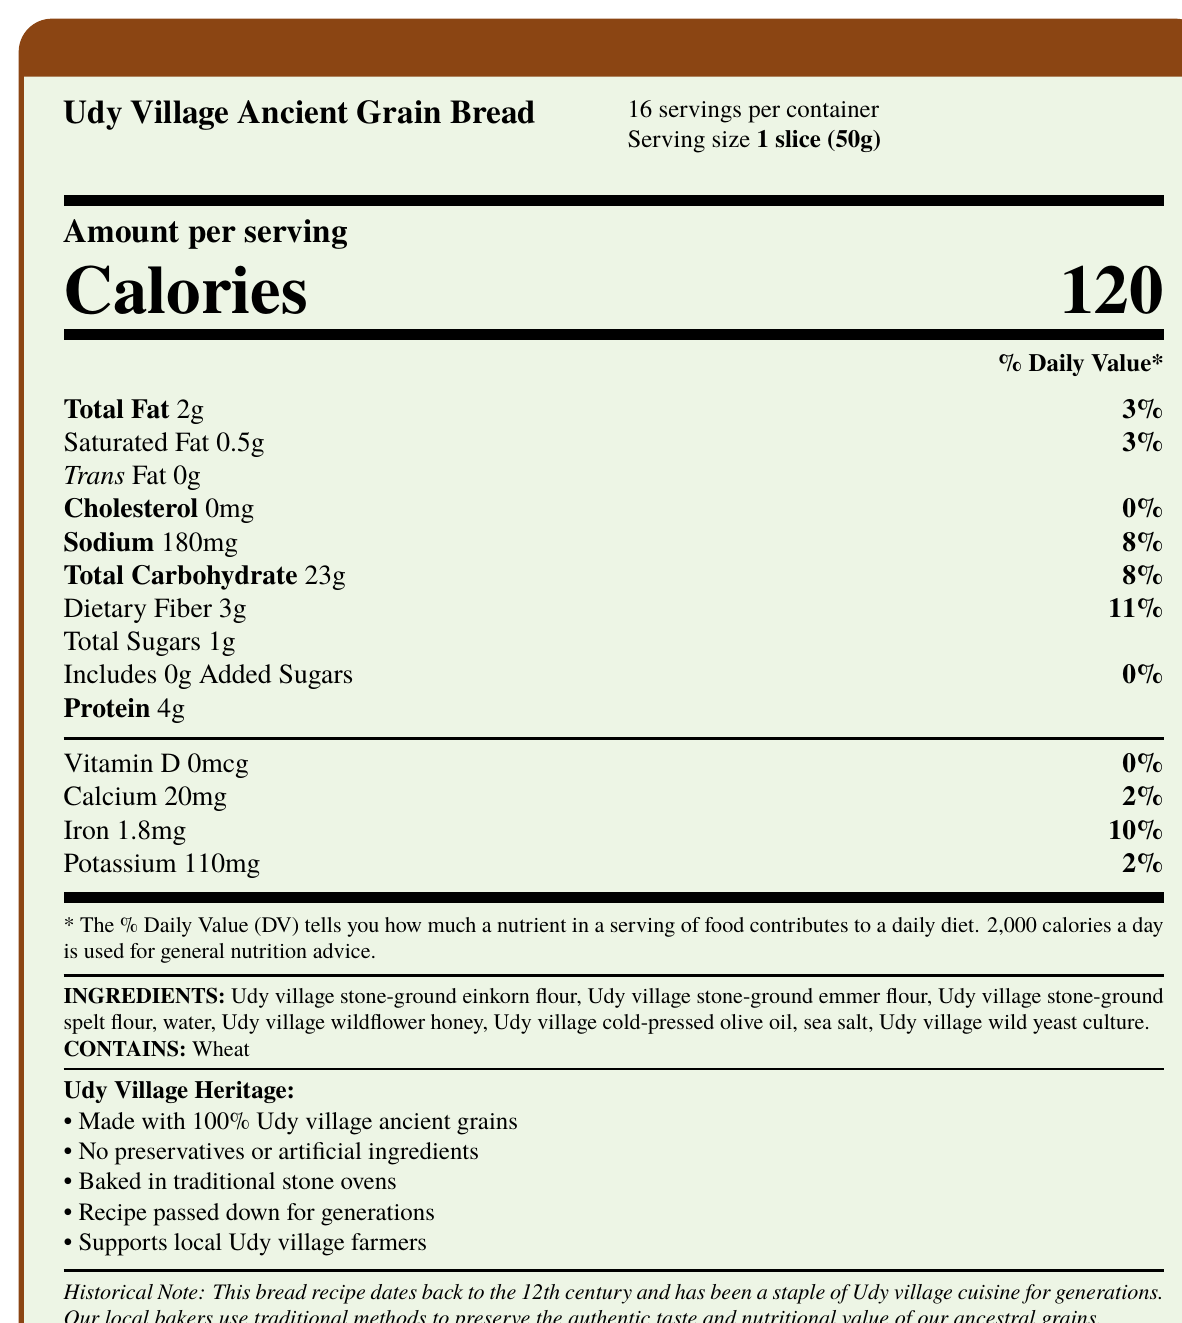what is the product name? The product name is clearly stated at the top of the document: "Udy Village Ancient Grain Bread."
Answer: Udy Village Ancient Grain Bread what is the serving size? The serving size is listed under the product name as "1 slice (50g)."
Answer: 1 slice (50g) how many calories per serving? The number of calories per serving is prominently displayed in the middle of the document as "Calories 120."
Answer: 120 what is the amount of total fat per serving? The total fat per serving is listed under "Amount per serving" as "Total Fat 2g."
Answer: 2g what are the three types of ancient grains used in the bread? The ingredients list includes "Udy village stone-ground einkorn flour," "Udy village stone-ground emmer flour," and "Udy village stone-ground spelt flour."
Answer: Einkorn, Emmer, Spelt which mineral contributes 10% to the DV? A. Calcium B. Iron C. Potassium D. Vitamin D The document shows "Iron 1.8mg" contributing to "10%" of the Daily Value (DV).
Answer: B. Iron what is the ingredient that acts as a sweetener in the bread? A. Sea salt B. Udy village wildflower honey C. Udy village cold-pressed olive oil D. Udy village wild yeast culture The ingredient list includes "Udy village wildflower honey," which acts as a sweetener.
Answer: B. Udy village wildflower honey does this bread contain any added sugars? The "Added Sugars" value is "0g" indicating that the bread does not contain any added sugars.
Answer: No is the bread made with preservative or artificial ingredients? The "additional info" section states that the bread has "No preservatives or artificial ingredients."
Answer: No summarize the main idea of this document. The document outlines the nutritional content per serving, the ingredients used, and additional notes about the traditional and local methods of making the bread, emphasizing its historical and cultural importance.
Answer: This document provides the Nutrition Facts, ingredients, and additional information about Udy Village Ancient Grain Bread. It highlights the use of 100% Udy village ancient grains, absence of preservatives, traditional baking methods, and the recipe dating back to the 12th century. how much dietary fiber is in one slice of bread? The dietary fiber per serving is listed as "Dietary Fiber 3g."
Answer: 3g how many servings are there in a container? The document states "16 servings per container" right below the product name.
Answer: 16 what percentage of the daily value for sodium is provided per serving? The document shows "Sodium 180mg" which accounts for "8%" of the Daily Value.
Answer: 8% which ingredient is not mentioned in the Nutrition Facts Label? A. Udy village stone-ground einkorn flour B. Udy village wildflower honey C. Udy village wild yeast culture D. Udy village old chili sauce The ingredient list does not include "Udy village old chili sauce."
Answer: D. Udy village old chili sauce what percentage of the daily value does calcium contribute? The document lists "Calcium 20mg" as contributing to "2%" of the Daily Value.
Answer: 2% what should you know about the historical aspect of this bread? The "historical_note" states that the recipe is from the 12th century and has been a staple, preserved with traditional baking methods.
Answer: The bread recipe dates back to the 12th century and is a staple of Udy village cuisine, made with traditional methods. what is the amount of trans fat per serving? The document states “Trans Fat 0g.”
Answer: 0g how much protein is in a serving size of this bread? The protein content per serving is listed as "Protein 4g."
Answer: 4g can you determine the price of this bread from the document? The document does not provide any information about the price of the bread.
Answer: Cannot be determined which allergens are present in the bread? The "allergens" section specifies "Contains: Wheat."
Answer: Wheat 